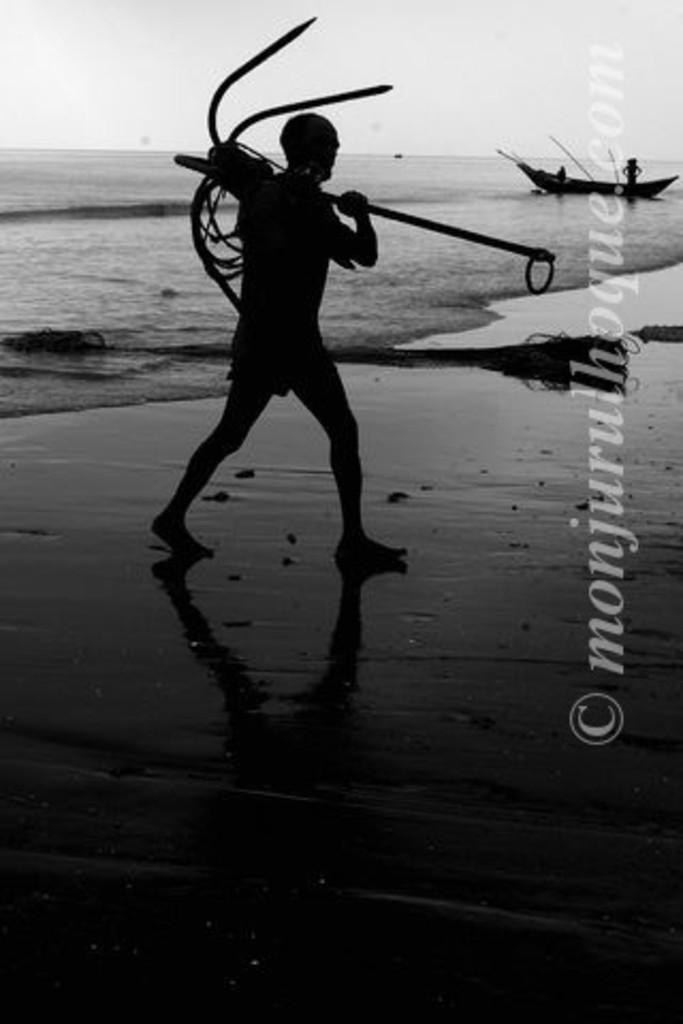Provide a one-sentence caption for the provided image. a man carries a big anchor by a watermark reading Monjurulhoque. 